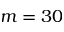<formula> <loc_0><loc_0><loc_500><loc_500>m = 3 0</formula> 